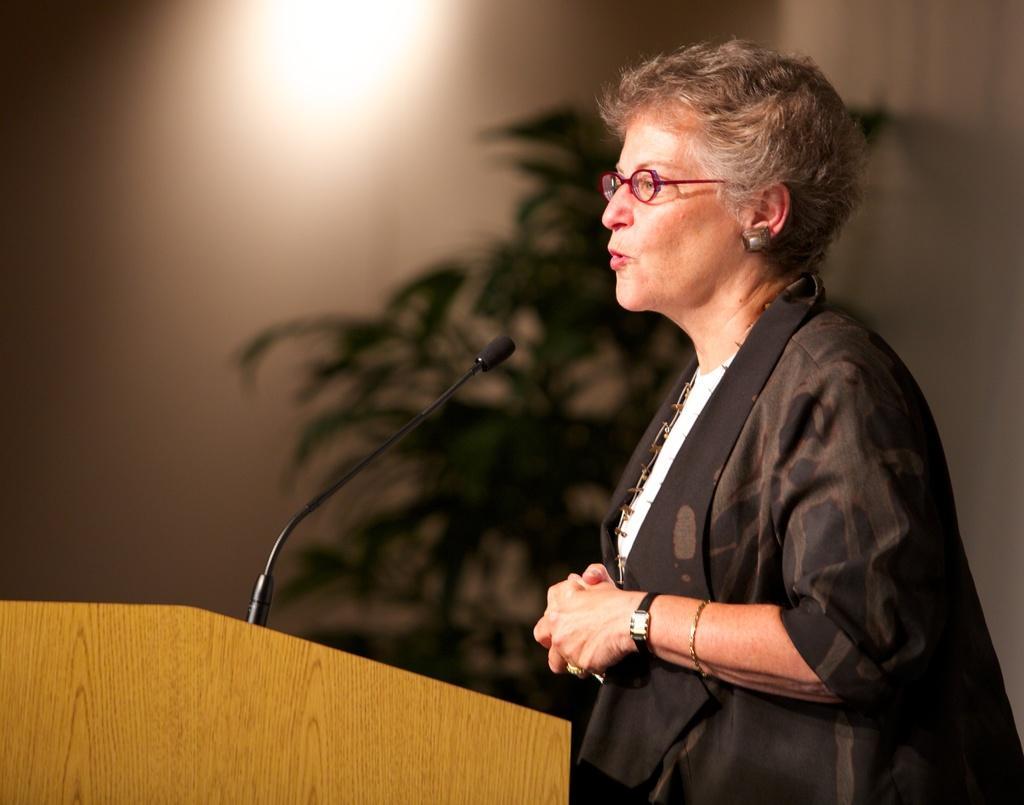Could you give a brief overview of what you see in this image? On the right of this picture we can see a person standing and seems to be talking. On the left we can see a microphone attached to the wooden podium. In the background we can see the light and a plant. 